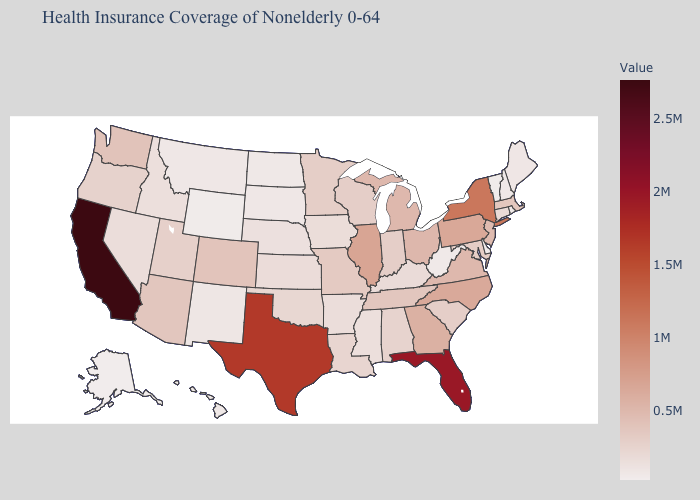Does Alaska have the highest value in the USA?
Quick response, please. No. Among the states that border Oklahoma , does Missouri have the lowest value?
Quick response, please. No. Which states hav the highest value in the Northeast?
Keep it brief. New York. 